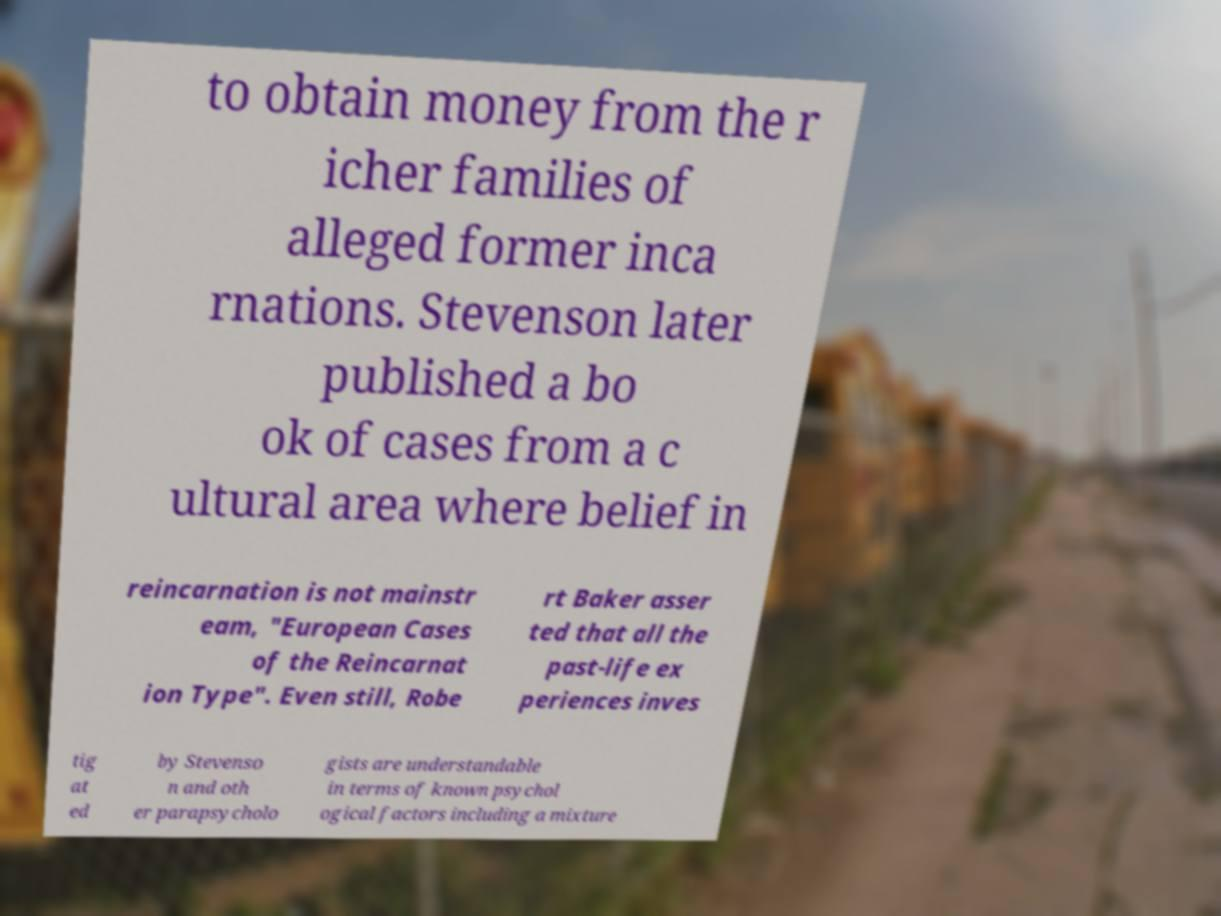What messages or text are displayed in this image? I need them in a readable, typed format. to obtain money from the r icher families of alleged former inca rnations. Stevenson later published a bo ok of cases from a c ultural area where belief in reincarnation is not mainstr eam, "European Cases of the Reincarnat ion Type". Even still, Robe rt Baker asser ted that all the past-life ex periences inves tig at ed by Stevenso n and oth er parapsycholo gists are understandable in terms of known psychol ogical factors including a mixture 